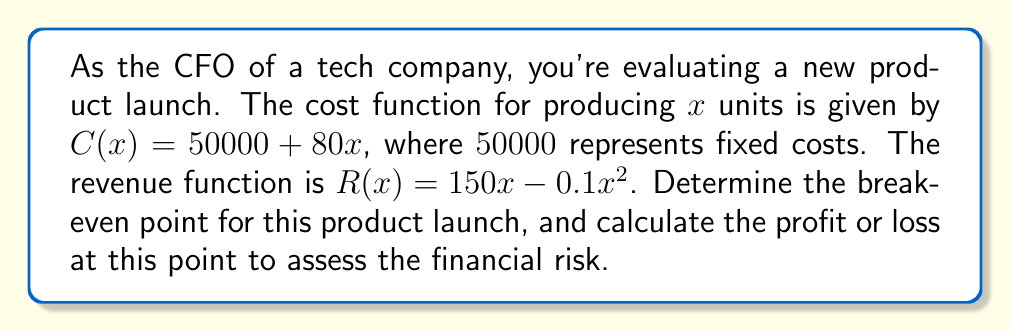Show me your answer to this math problem. To solve this problem, we'll follow these steps:

1) The break-even point occurs where the cost function equals the revenue function. So, we need to solve:

   $C(x) = R(x)$

2) Substituting the given functions:

   $50000 + 80x = 150x - 0.1x^2$

3) Rearranging the equation:

   $0.1x^2 - 70x + 50000 = 0$

4) This is a quadratic equation. We can solve it using the quadratic formula:

   $x = \frac{-b \pm \sqrt{b^2 - 4ac}}{2a}$

   Where $a = 0.1$, $b = -70$, and $c = 50000$

5) Substituting these values:

   $x = \frac{70 \pm \sqrt{(-70)^2 - 4(0.1)(50000)}}{2(0.1)}$

6) Simplifying:

   $x = \frac{70 \pm \sqrt{4900 - 20000}}{0.2} = \frac{70 \pm \sqrt{-15100}}{0.2}$

7) Since we can't have a negative value under the square root, there's only one real solution:

   $x = \frac{70 + \sqrt{15100}}{0.2} \approx 793.87$

8) Rounding up to the nearest whole unit, the break-even point is at 794 units.

9) To calculate the profit or loss at this point, we can substitute this value into either the cost or revenue function:

   $C(794) = 50000 + 80(794) = 113520$
   $R(794) = 150(794) - 0.1(794)^2 = 113506.4$

10) The difference between revenue and cost at this point is:

    $113506.4 - 113520 = -13.6$

This small negative value is due to rounding up to the nearest whole unit.
Answer: The break-even point is 794 units. At this point, there is a negligible loss of $13.60, effectively breaking even. 